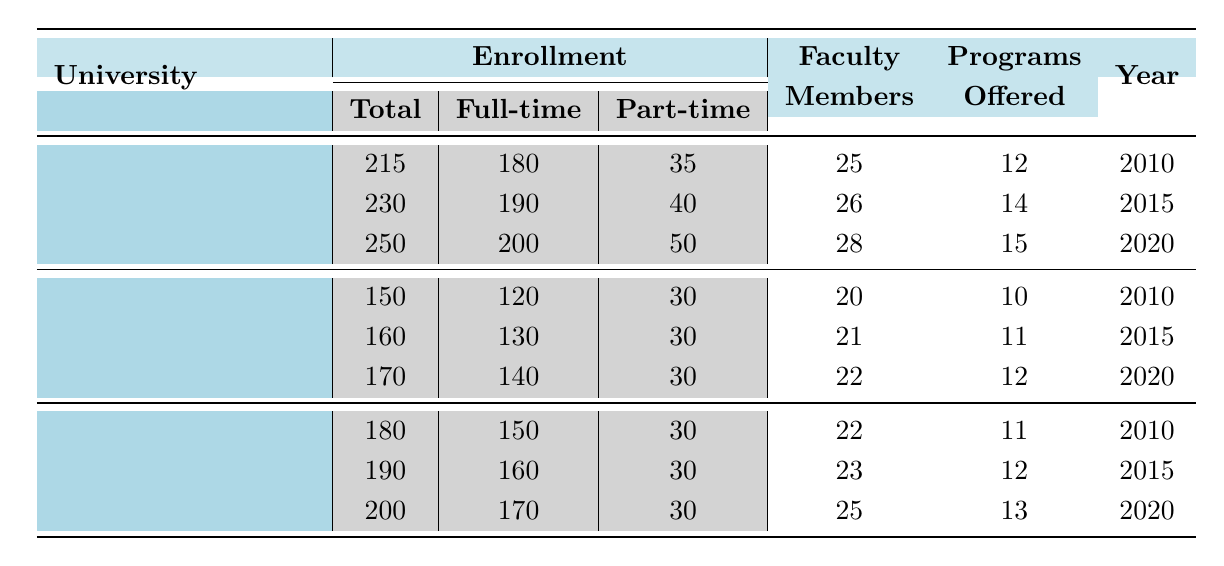What was the enrollment at Harvard University in 2010? Referring to the table, the enrollment for Harvard University in 2010 is listed as 215.
Answer: 215 How many faculty members were there at Stanford University in 2015? The table shows that Stanford University had 21 faculty members in 2015.
Answer: 21 What is the total enrollment for the University of Chicago across all years? Adding the enrollments for the University of Chicago: 180 (2010) + 190 (2015) + 200 (2020) = 570.
Answer: 570 What was the increase in full-time enrollment at Harvard University from 2010 to 2020? The full-time enrollment at Harvard University was 180 in 2010 and increased to 200 in 2020. The difference is 200 - 180 = 20.
Answer: 20 Which university had the highest total enrollment in 2020? In 2020, the enrollments were: Harvard University 250, Stanford University 170, University of Chicago 200. Harvard University had the highest enrollment.
Answer: Harvard University Is the statement "Stanford University had more full-time students than part-time students in 2015" true or false? According to the table, Stanford University had 130 full-time and 30 part-time students in 2015, which confirms the statement as true.
Answer: True What is the average number of programs offered at the University of Chicago throughout the years listed? The programs offered at the University of Chicago were: 11 (2010), 12 (2015), 13 (2020). The average is (11 + 12 + 13) / 3 = 12.
Answer: 12 Which university had the smallest number of programs offered in 2010? Referring to the table for 2010: Harvard University offered 12, Stanford University 10, University of Chicago 11. Stanford University had the smallest number of programs.
Answer: Stanford University What was the overall trend in enrollment for Harvard University from 2010 to 2020? The enrollments for Harvard University were 215 in 2010, 230 in 2015, and 250 in 2020, showing a consistent increase each year.
Answer: Increasing How many more part-time students were there at Harvard University compared to Stanford University in 2020? For Harvard University, the part-time enrollment in 2020 was 50, and for Stanford University, it was 30. The difference is 50 - 30 = 20.
Answer: 20 